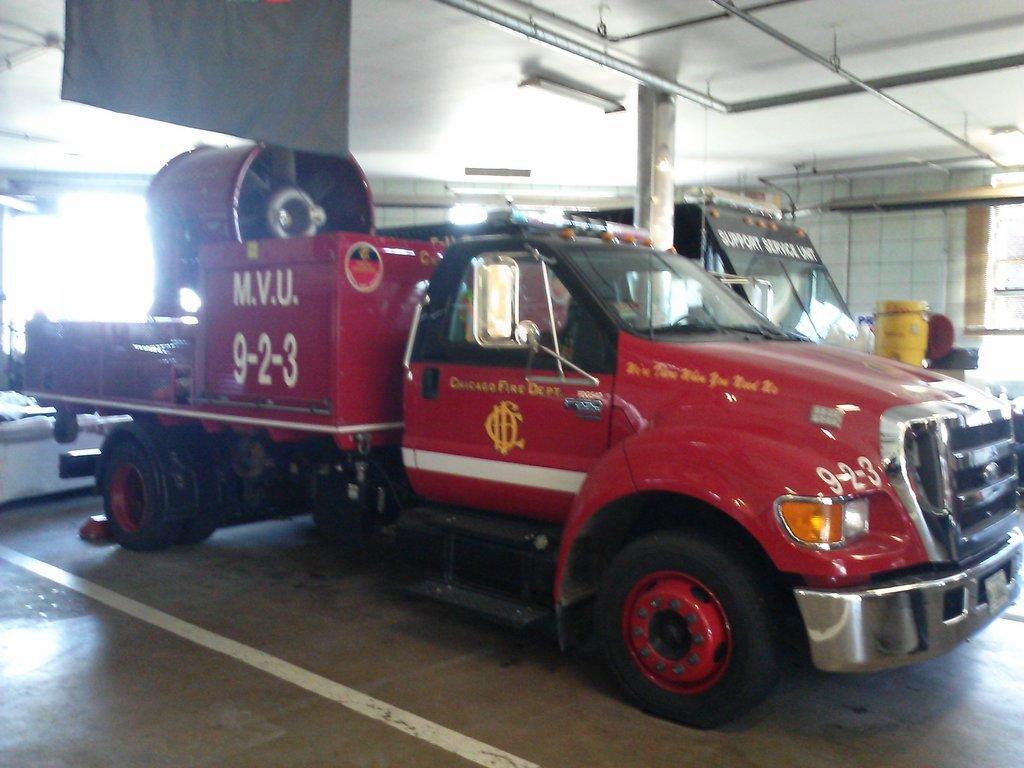In one or two sentences, can you explain what this image depicts? This is a garage and here we can see vehicles and in the background, there are containers and we can see a pillar, lights, banner, rods and some other objects. At the top, there is roof and at the bottom, there is floor. 